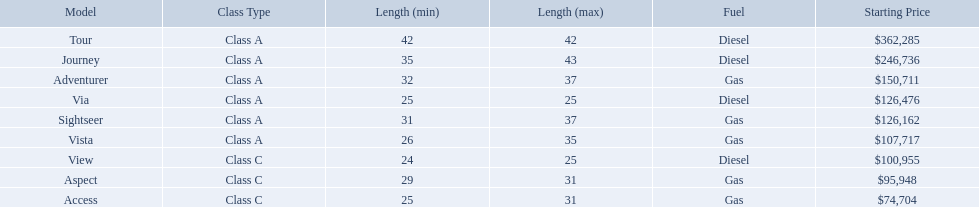Which models are manufactured by winnebago industries? Tour, Journey, Adventurer, Via, Sightseer, Vista, View, Aspect, Access. What type of fuel does each model require? Diesel, Diesel, Gas, Diesel, Gas, Gas, Diesel, Gas, Gas. And between the tour and aspect, which runs on diesel? Tour. Which models of winnebago are there? Tour, Journey, Adventurer, Via, Sightseer, Vista, View, Aspect, Access. Which ones are diesel? Tour, Journey, Sightseer, View. Which of those is the longest? Tour, Journey. Which one has the highest starting price? Tour. What are the prices? $362,285, $246,736, $150,711, $126,476, $126,162, $107,717, $100,955, $95,948, $74,704. What is the top price? $362,285. What model has this price? Tour. 